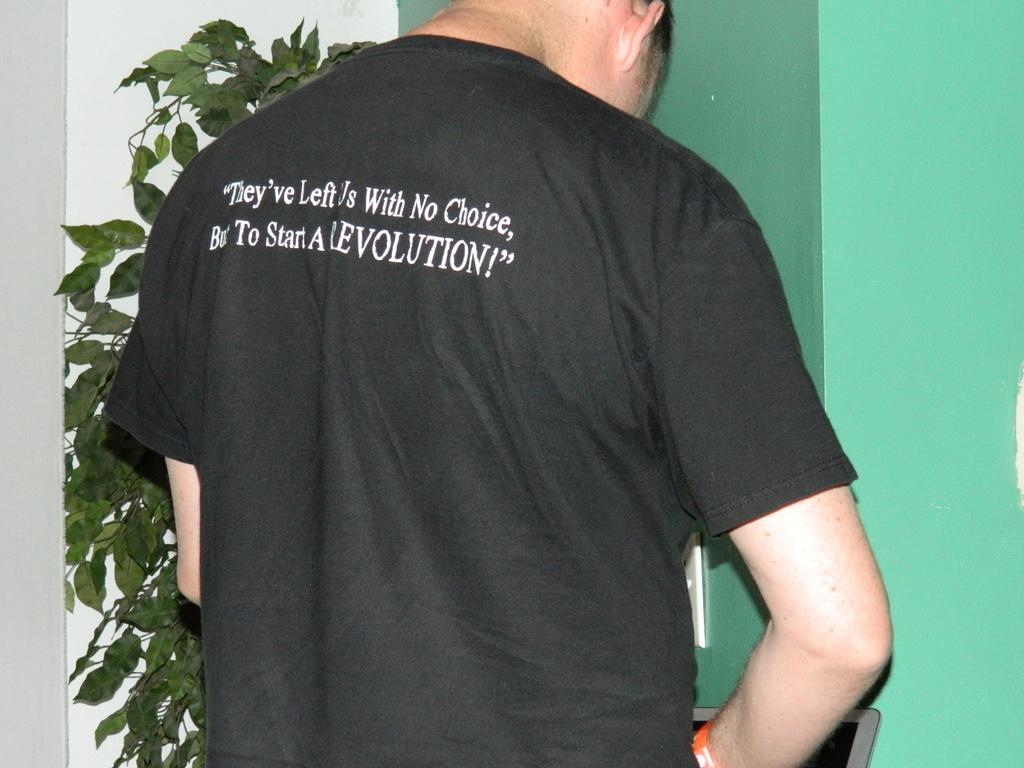What does the shirt say needs to be started?
Give a very brief answer. Revolution. 